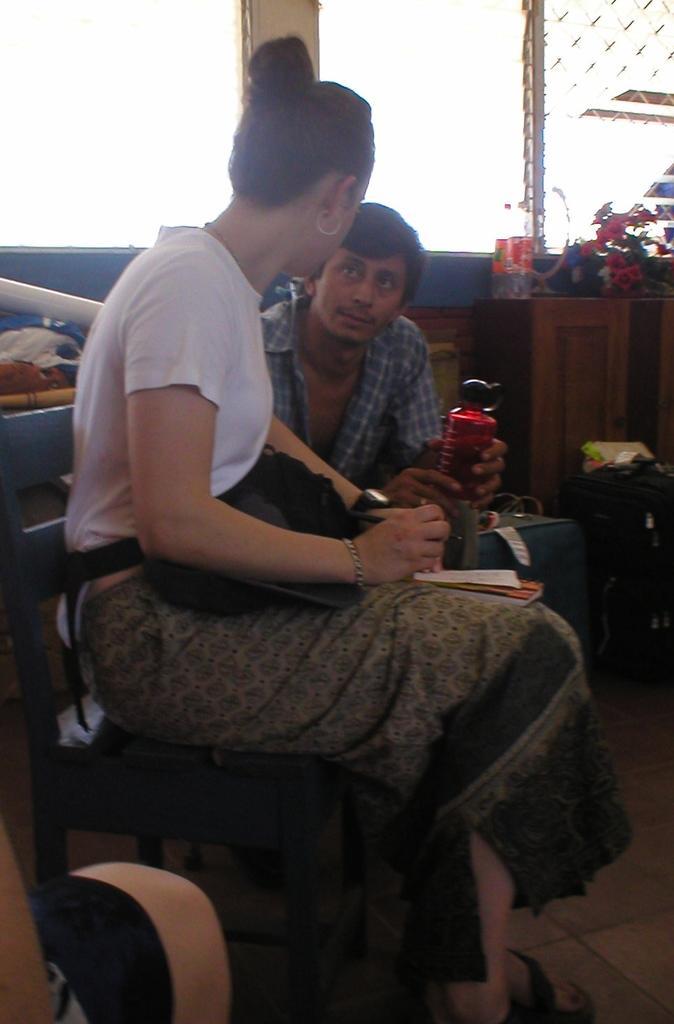Describe this image in one or two sentences. In this image we can see a lady sitting on a chair. She is holding pen and some other things. In the back there is a person holding bottle. Also there is a table. On that there are bottles, flowers and some other items. Also there are few other objects. 